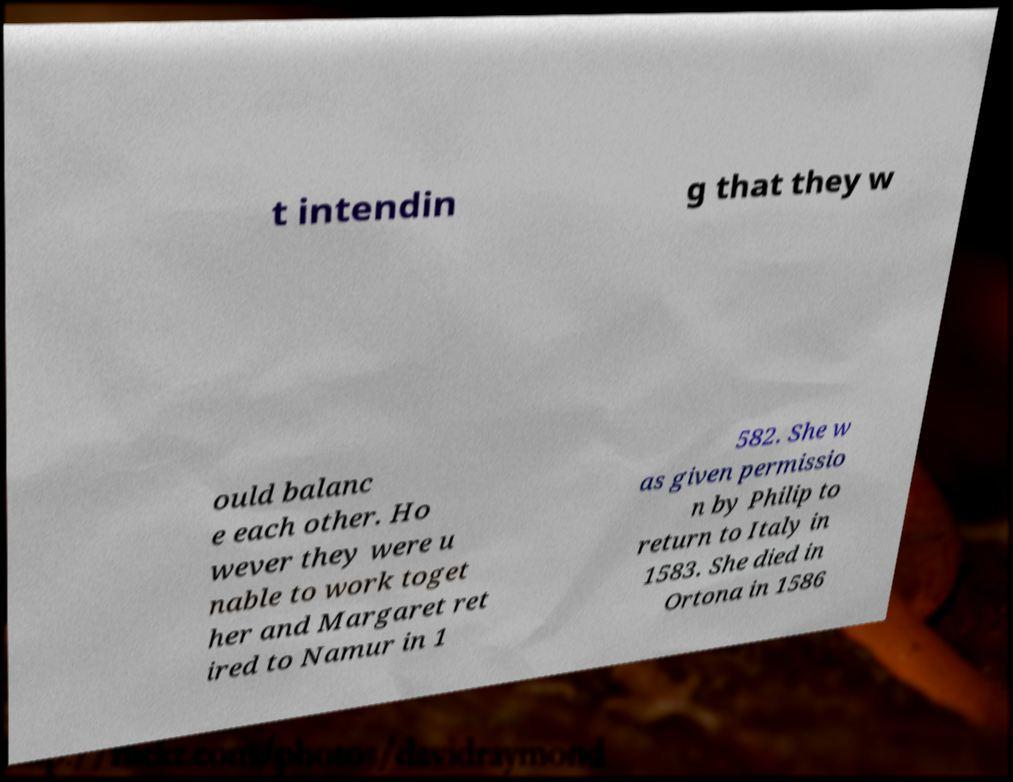Please read and relay the text visible in this image. What does it say? t intendin g that they w ould balanc e each other. Ho wever they were u nable to work toget her and Margaret ret ired to Namur in 1 582. She w as given permissio n by Philip to return to Italy in 1583. She died in Ortona in 1586 